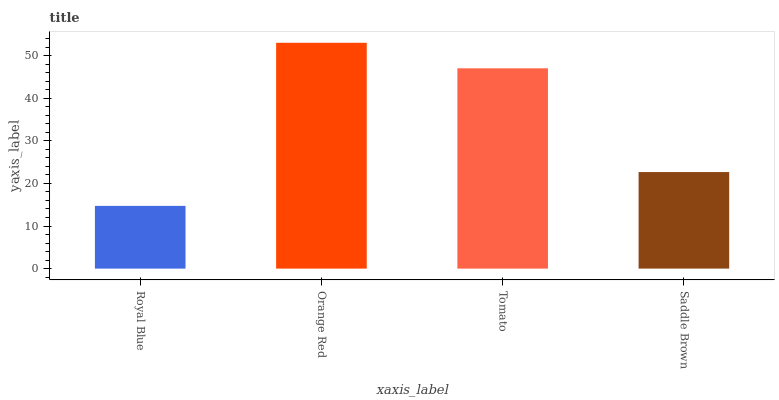Is Royal Blue the minimum?
Answer yes or no. Yes. Is Orange Red the maximum?
Answer yes or no. Yes. Is Tomato the minimum?
Answer yes or no. No. Is Tomato the maximum?
Answer yes or no. No. Is Orange Red greater than Tomato?
Answer yes or no. Yes. Is Tomato less than Orange Red?
Answer yes or no. Yes. Is Tomato greater than Orange Red?
Answer yes or no. No. Is Orange Red less than Tomato?
Answer yes or no. No. Is Tomato the high median?
Answer yes or no. Yes. Is Saddle Brown the low median?
Answer yes or no. Yes. Is Saddle Brown the high median?
Answer yes or no. No. Is Royal Blue the low median?
Answer yes or no. No. 